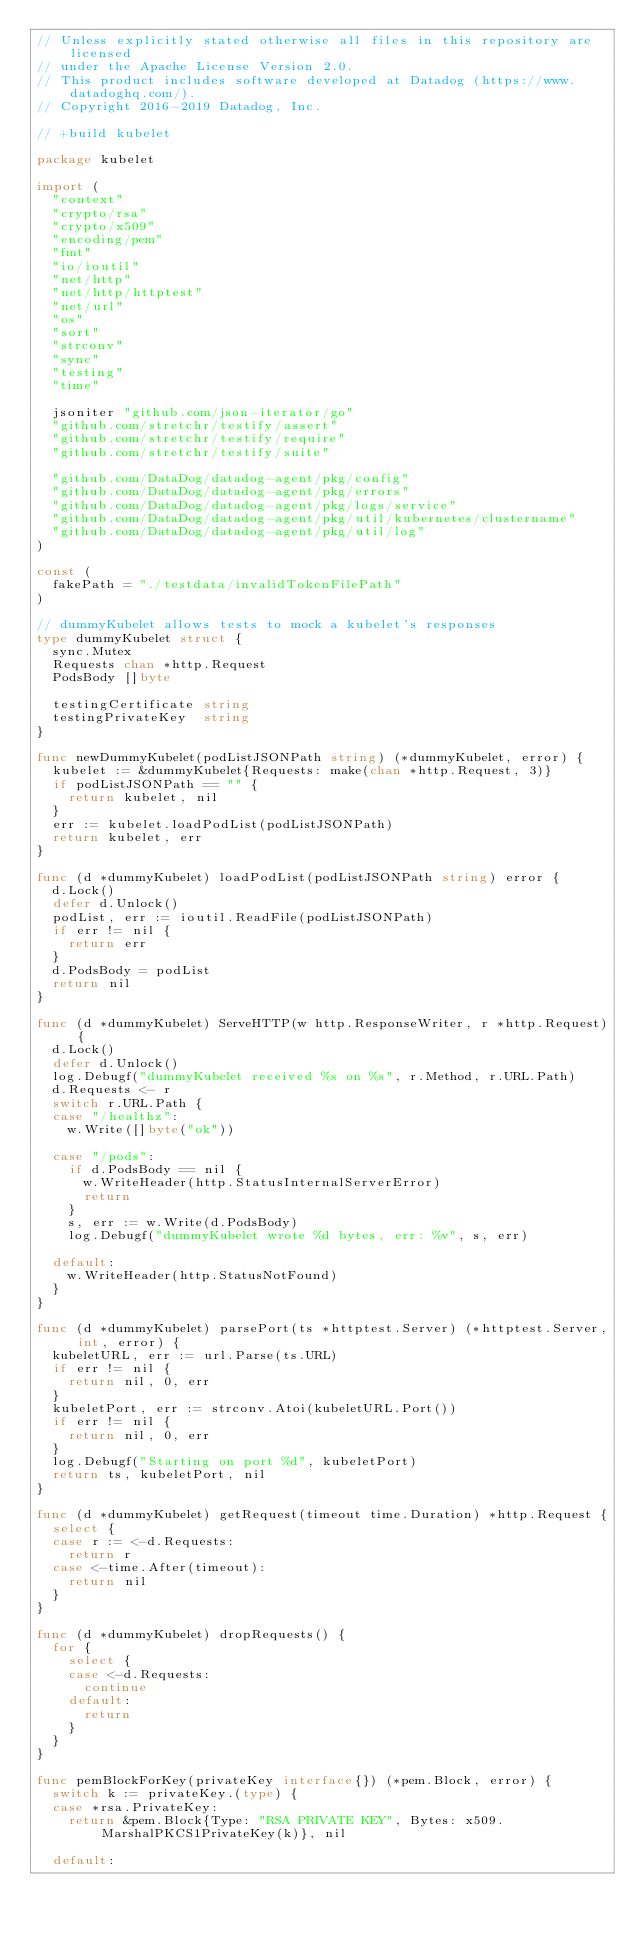Convert code to text. <code><loc_0><loc_0><loc_500><loc_500><_Go_>// Unless explicitly stated otherwise all files in this repository are licensed
// under the Apache License Version 2.0.
// This product includes software developed at Datadog (https://www.datadoghq.com/).
// Copyright 2016-2019 Datadog, Inc.

// +build kubelet

package kubelet

import (
	"context"
	"crypto/rsa"
	"crypto/x509"
	"encoding/pem"
	"fmt"
	"io/ioutil"
	"net/http"
	"net/http/httptest"
	"net/url"
	"os"
	"sort"
	"strconv"
	"sync"
	"testing"
	"time"

	jsoniter "github.com/json-iterator/go"
	"github.com/stretchr/testify/assert"
	"github.com/stretchr/testify/require"
	"github.com/stretchr/testify/suite"

	"github.com/DataDog/datadog-agent/pkg/config"
	"github.com/DataDog/datadog-agent/pkg/errors"
	"github.com/DataDog/datadog-agent/pkg/logs/service"
	"github.com/DataDog/datadog-agent/pkg/util/kubernetes/clustername"
	"github.com/DataDog/datadog-agent/pkg/util/log"
)

const (
	fakePath = "./testdata/invalidTokenFilePath"
)

// dummyKubelet allows tests to mock a kubelet's responses
type dummyKubelet struct {
	sync.Mutex
	Requests chan *http.Request
	PodsBody []byte

	testingCertificate string
	testingPrivateKey  string
}

func newDummyKubelet(podListJSONPath string) (*dummyKubelet, error) {
	kubelet := &dummyKubelet{Requests: make(chan *http.Request, 3)}
	if podListJSONPath == "" {
		return kubelet, nil
	}
	err := kubelet.loadPodList(podListJSONPath)
	return kubelet, err
}

func (d *dummyKubelet) loadPodList(podListJSONPath string) error {
	d.Lock()
	defer d.Unlock()
	podList, err := ioutil.ReadFile(podListJSONPath)
	if err != nil {
		return err
	}
	d.PodsBody = podList
	return nil
}

func (d *dummyKubelet) ServeHTTP(w http.ResponseWriter, r *http.Request) {
	d.Lock()
	defer d.Unlock()
	log.Debugf("dummyKubelet received %s on %s", r.Method, r.URL.Path)
	d.Requests <- r
	switch r.URL.Path {
	case "/healthz":
		w.Write([]byte("ok"))

	case "/pods":
		if d.PodsBody == nil {
			w.WriteHeader(http.StatusInternalServerError)
			return
		}
		s, err := w.Write(d.PodsBody)
		log.Debugf("dummyKubelet wrote %d bytes, err: %v", s, err)

	default:
		w.WriteHeader(http.StatusNotFound)
	}
}

func (d *dummyKubelet) parsePort(ts *httptest.Server) (*httptest.Server, int, error) {
	kubeletURL, err := url.Parse(ts.URL)
	if err != nil {
		return nil, 0, err
	}
	kubeletPort, err := strconv.Atoi(kubeletURL.Port())
	if err != nil {
		return nil, 0, err
	}
	log.Debugf("Starting on port %d", kubeletPort)
	return ts, kubeletPort, nil
}

func (d *dummyKubelet) getRequest(timeout time.Duration) *http.Request {
	select {
	case r := <-d.Requests:
		return r
	case <-time.After(timeout):
		return nil
	}
}

func (d *dummyKubelet) dropRequests() {
	for {
		select {
		case <-d.Requests:
			continue
		default:
			return
		}
	}
}

func pemBlockForKey(privateKey interface{}) (*pem.Block, error) {
	switch k := privateKey.(type) {
	case *rsa.PrivateKey:
		return &pem.Block{Type: "RSA PRIVATE KEY", Bytes: x509.MarshalPKCS1PrivateKey(k)}, nil

	default:</code> 